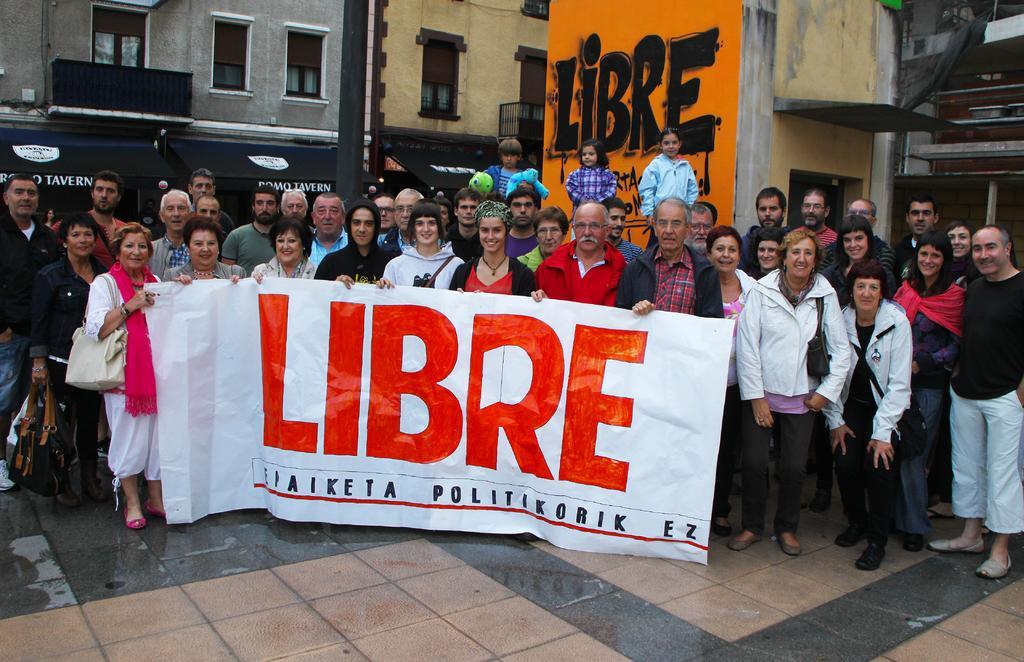Could you give a brief overview of what you see in this image? In the center of the image a group of people are standing. Some of them are holding a banner and some of them are carrying their bags. In the background of the image we can see buildings, windows, graffiti, sheds, wall are there. At the bottom of the image ground is there. 